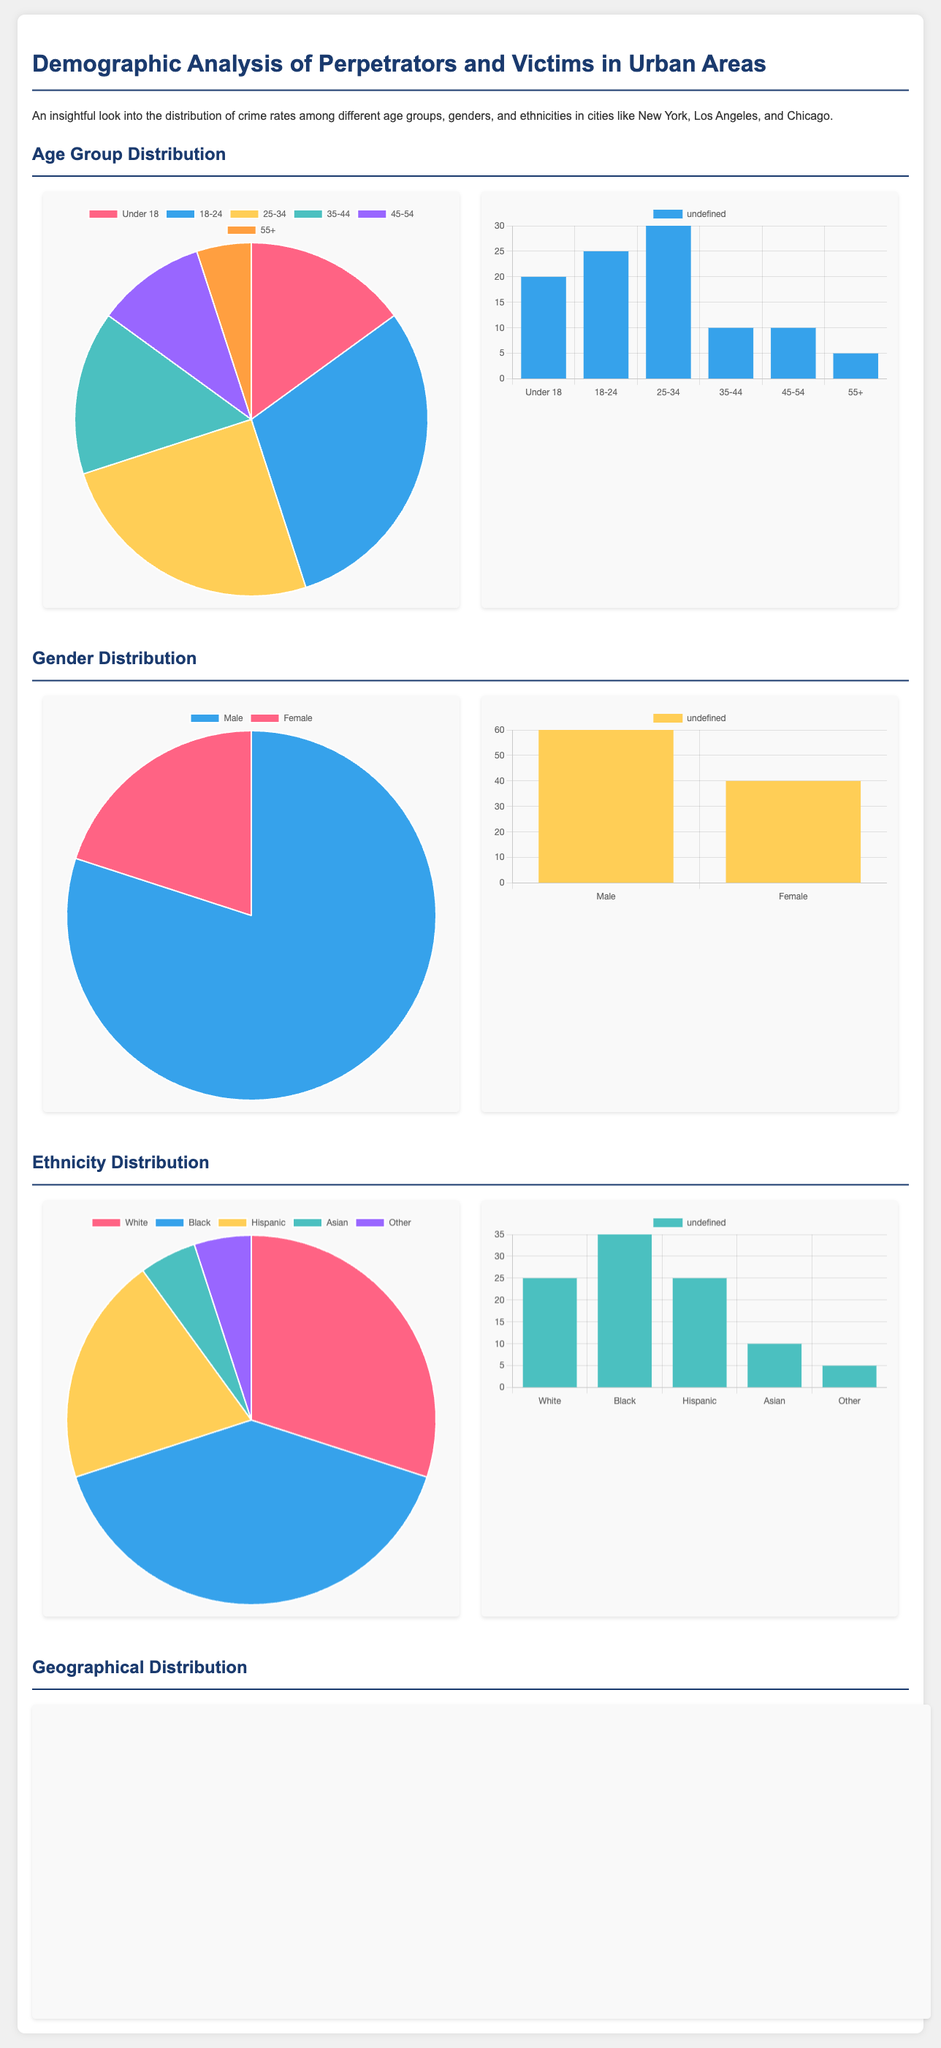What age group has the highest percentage of perpetrators? The pie chart for perpetrators by age group shows that the age group 18-24 has the highest percentage at 30%.
Answer: 18-24 How many victims are aged 35-44 in Los Angeles? The bar graph for victims by age group indicates that there are 10 victims aged 35-44.
Answer: 10 What percentage of perpetrators are female in Chicago? The pie chart for perpetrators by gender shows that 20% of perpetrators are female.
Answer: 20% Which ethnicity has the highest percentage of victims in Chicago? The bar graph for victims by ethnicity shows that the Black ethnicity has the highest percentage at 35%.
Answer: Black What is the total number of crime rates from neighborhoods in New York City presented in the document? The bar graph for crime rates by neighborhoods shows a total of 400 (150 + 100 + 75 + 50 + 25).
Answer: 400 Which gender is most victimized in New York City? The bar graph for victims by gender indicates that males are more victimized at 60%.
Answer: Male What percentage of perpetrators are Hispanic in Los Angeles? The pie chart for perpetrators by ethnicity states that 20% of perpetrators are Hispanic.
Answer: 20% Which neighborhood has the highest crime rate? The bar graph shows that Manhattan has the highest crime rate at 150.
Answer: Manhattan What is the age group with the least number of victims aged 55 and above? The bar graph for victims by age group indicates that the age group 55+ has 5 victims, which is the least.
Answer: 5 